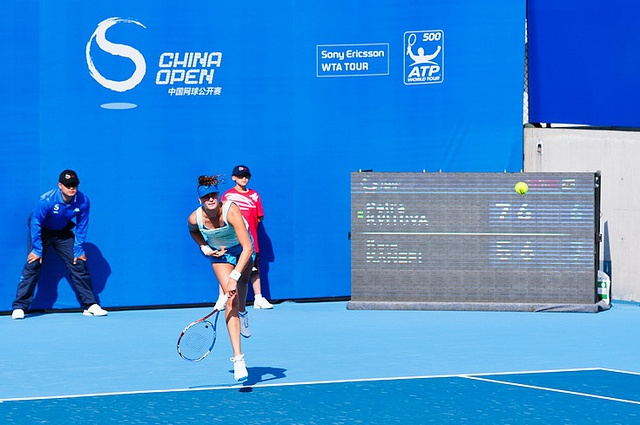Describe the objects in this image and their specific colors. I can see people in blue, salmon, white, black, and tan tones, people in blue, navy, black, and darkblue tones, people in blue, white, brown, navy, and black tones, tennis racket in blue, lightblue, and white tones, and sports ball in blue, khaki, and yellow tones in this image. 